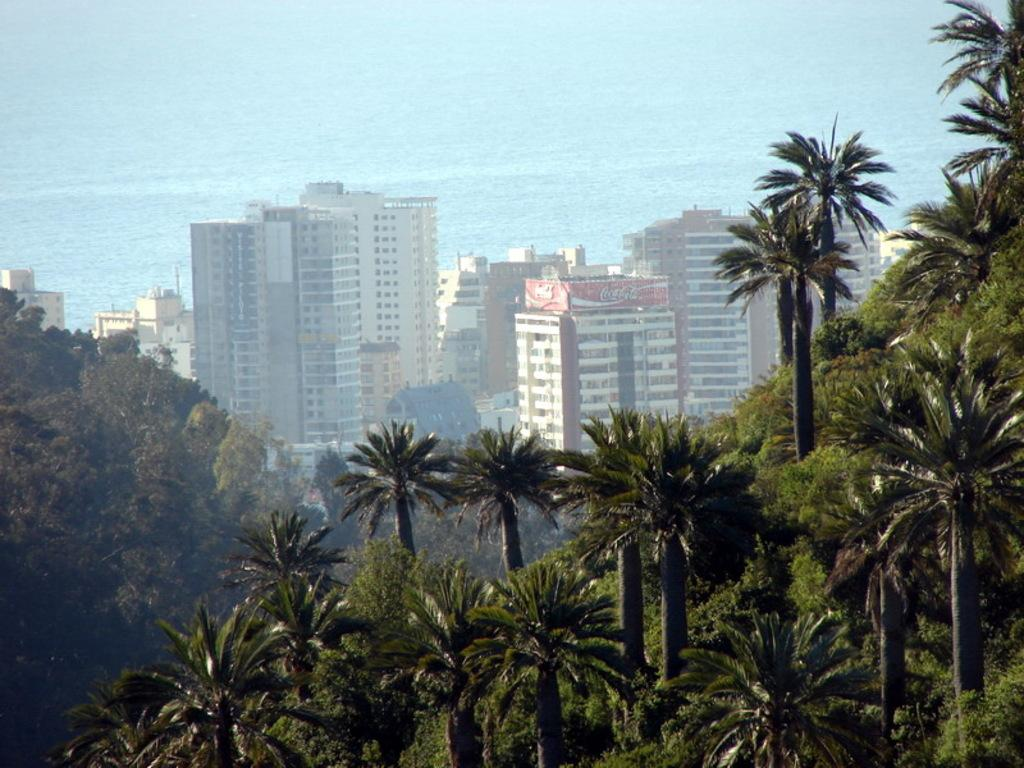What is located in the center of the image? There are buildings and trees in the center of the image. Can you describe the buildings in the image? The provided facts do not give specific details about the buildings, so we cannot describe them further. What can be seen in the background of the image? There is water visible in the background of the image. How many bubbles are floating above the trees in the image? There are no bubbles present in the image; it features buildings, trees, and water in the background. 